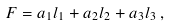<formula> <loc_0><loc_0><loc_500><loc_500>F = a _ { 1 } l _ { 1 } + a _ { 2 } l _ { 2 } + a _ { 3 } l _ { 3 } \, ,</formula> 